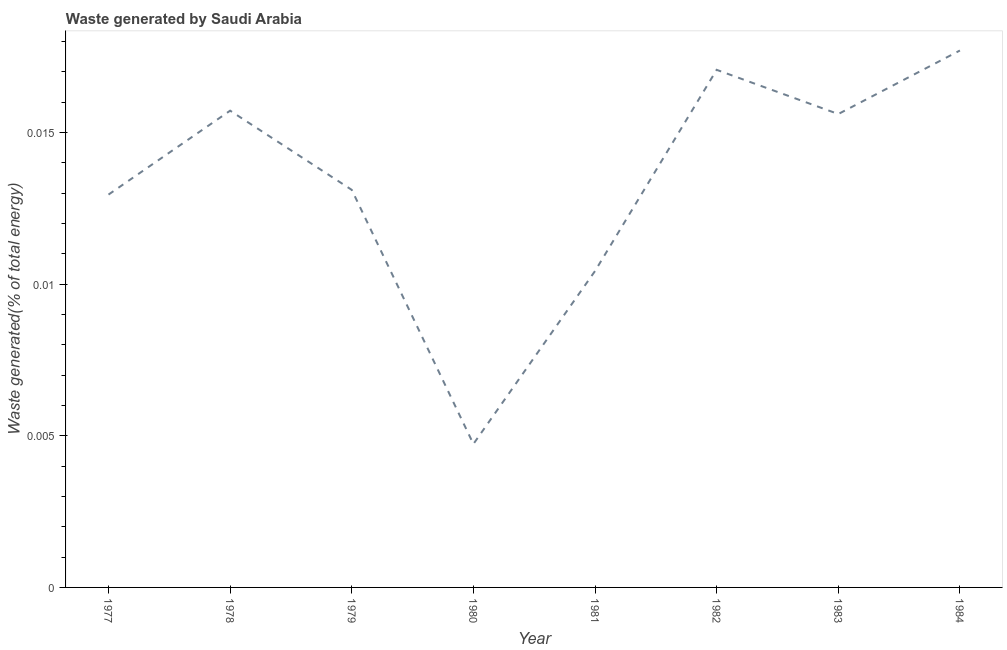What is the amount of waste generated in 1978?
Your response must be concise. 0.02. Across all years, what is the maximum amount of waste generated?
Offer a terse response. 0.02. Across all years, what is the minimum amount of waste generated?
Offer a very short reply. 0. What is the sum of the amount of waste generated?
Your answer should be compact. 0.11. What is the difference between the amount of waste generated in 1982 and 1984?
Your answer should be very brief. -0. What is the average amount of waste generated per year?
Make the answer very short. 0.01. What is the median amount of waste generated?
Keep it short and to the point. 0.01. Do a majority of the years between 1979 and 1983 (inclusive) have amount of waste generated greater than 0.009000000000000001 %?
Offer a terse response. Yes. What is the ratio of the amount of waste generated in 1977 to that in 1983?
Provide a succinct answer. 0.83. Is the amount of waste generated in 1978 less than that in 1981?
Ensure brevity in your answer.  No. Is the difference between the amount of waste generated in 1979 and 1982 greater than the difference between any two years?
Make the answer very short. No. What is the difference between the highest and the second highest amount of waste generated?
Provide a succinct answer. 0. Is the sum of the amount of waste generated in 1978 and 1983 greater than the maximum amount of waste generated across all years?
Offer a terse response. Yes. What is the difference between the highest and the lowest amount of waste generated?
Keep it short and to the point. 0.01. In how many years, is the amount of waste generated greater than the average amount of waste generated taken over all years?
Give a very brief answer. 4. How many lines are there?
Offer a very short reply. 1. What is the difference between two consecutive major ticks on the Y-axis?
Give a very brief answer. 0.01. What is the title of the graph?
Provide a succinct answer. Waste generated by Saudi Arabia. What is the label or title of the X-axis?
Offer a terse response. Year. What is the label or title of the Y-axis?
Your answer should be compact. Waste generated(% of total energy). What is the Waste generated(% of total energy) in 1977?
Offer a terse response. 0.01. What is the Waste generated(% of total energy) of 1978?
Keep it short and to the point. 0.02. What is the Waste generated(% of total energy) in 1979?
Provide a succinct answer. 0.01. What is the Waste generated(% of total energy) of 1980?
Keep it short and to the point. 0. What is the Waste generated(% of total energy) in 1981?
Your answer should be very brief. 0.01. What is the Waste generated(% of total energy) in 1982?
Offer a very short reply. 0.02. What is the Waste generated(% of total energy) of 1983?
Keep it short and to the point. 0.02. What is the Waste generated(% of total energy) of 1984?
Offer a very short reply. 0.02. What is the difference between the Waste generated(% of total energy) in 1977 and 1978?
Ensure brevity in your answer.  -0. What is the difference between the Waste generated(% of total energy) in 1977 and 1979?
Provide a succinct answer. -0. What is the difference between the Waste generated(% of total energy) in 1977 and 1980?
Your answer should be compact. 0.01. What is the difference between the Waste generated(% of total energy) in 1977 and 1981?
Make the answer very short. 0. What is the difference between the Waste generated(% of total energy) in 1977 and 1982?
Provide a short and direct response. -0. What is the difference between the Waste generated(% of total energy) in 1977 and 1983?
Keep it short and to the point. -0. What is the difference between the Waste generated(% of total energy) in 1977 and 1984?
Keep it short and to the point. -0. What is the difference between the Waste generated(% of total energy) in 1978 and 1979?
Ensure brevity in your answer.  0. What is the difference between the Waste generated(% of total energy) in 1978 and 1980?
Make the answer very short. 0.01. What is the difference between the Waste generated(% of total energy) in 1978 and 1981?
Make the answer very short. 0.01. What is the difference between the Waste generated(% of total energy) in 1978 and 1982?
Offer a terse response. -0. What is the difference between the Waste generated(% of total energy) in 1978 and 1983?
Provide a short and direct response. 0. What is the difference between the Waste generated(% of total energy) in 1978 and 1984?
Provide a short and direct response. -0. What is the difference between the Waste generated(% of total energy) in 1979 and 1980?
Offer a terse response. 0.01. What is the difference between the Waste generated(% of total energy) in 1979 and 1981?
Keep it short and to the point. 0. What is the difference between the Waste generated(% of total energy) in 1979 and 1982?
Your answer should be very brief. -0. What is the difference between the Waste generated(% of total energy) in 1979 and 1983?
Your response must be concise. -0. What is the difference between the Waste generated(% of total energy) in 1979 and 1984?
Provide a short and direct response. -0. What is the difference between the Waste generated(% of total energy) in 1980 and 1981?
Provide a short and direct response. -0.01. What is the difference between the Waste generated(% of total energy) in 1980 and 1982?
Your response must be concise. -0.01. What is the difference between the Waste generated(% of total energy) in 1980 and 1983?
Keep it short and to the point. -0.01. What is the difference between the Waste generated(% of total energy) in 1980 and 1984?
Ensure brevity in your answer.  -0.01. What is the difference between the Waste generated(% of total energy) in 1981 and 1982?
Provide a succinct answer. -0.01. What is the difference between the Waste generated(% of total energy) in 1981 and 1983?
Ensure brevity in your answer.  -0.01. What is the difference between the Waste generated(% of total energy) in 1981 and 1984?
Your response must be concise. -0.01. What is the difference between the Waste generated(% of total energy) in 1982 and 1983?
Offer a very short reply. 0. What is the difference between the Waste generated(% of total energy) in 1982 and 1984?
Provide a short and direct response. -0. What is the difference between the Waste generated(% of total energy) in 1983 and 1984?
Your response must be concise. -0. What is the ratio of the Waste generated(% of total energy) in 1977 to that in 1978?
Your answer should be compact. 0.82. What is the ratio of the Waste generated(% of total energy) in 1977 to that in 1979?
Provide a short and direct response. 0.99. What is the ratio of the Waste generated(% of total energy) in 1977 to that in 1980?
Offer a very short reply. 2.74. What is the ratio of the Waste generated(% of total energy) in 1977 to that in 1981?
Provide a short and direct response. 1.24. What is the ratio of the Waste generated(% of total energy) in 1977 to that in 1982?
Your response must be concise. 0.76. What is the ratio of the Waste generated(% of total energy) in 1977 to that in 1983?
Provide a short and direct response. 0.83. What is the ratio of the Waste generated(% of total energy) in 1977 to that in 1984?
Ensure brevity in your answer.  0.73. What is the ratio of the Waste generated(% of total energy) in 1978 to that in 1979?
Your response must be concise. 1.2. What is the ratio of the Waste generated(% of total energy) in 1978 to that in 1980?
Offer a terse response. 3.32. What is the ratio of the Waste generated(% of total energy) in 1978 to that in 1981?
Make the answer very short. 1.51. What is the ratio of the Waste generated(% of total energy) in 1978 to that in 1982?
Your answer should be compact. 0.92. What is the ratio of the Waste generated(% of total energy) in 1978 to that in 1984?
Provide a succinct answer. 0.89. What is the ratio of the Waste generated(% of total energy) in 1979 to that in 1980?
Your response must be concise. 2.77. What is the ratio of the Waste generated(% of total energy) in 1979 to that in 1981?
Offer a very short reply. 1.26. What is the ratio of the Waste generated(% of total energy) in 1979 to that in 1982?
Your response must be concise. 0.77. What is the ratio of the Waste generated(% of total energy) in 1979 to that in 1983?
Offer a terse response. 0.84. What is the ratio of the Waste generated(% of total energy) in 1979 to that in 1984?
Your answer should be compact. 0.74. What is the ratio of the Waste generated(% of total energy) in 1980 to that in 1981?
Keep it short and to the point. 0.45. What is the ratio of the Waste generated(% of total energy) in 1980 to that in 1982?
Ensure brevity in your answer.  0.28. What is the ratio of the Waste generated(% of total energy) in 1980 to that in 1983?
Give a very brief answer. 0.3. What is the ratio of the Waste generated(% of total energy) in 1980 to that in 1984?
Keep it short and to the point. 0.27. What is the ratio of the Waste generated(% of total energy) in 1981 to that in 1982?
Your response must be concise. 0.61. What is the ratio of the Waste generated(% of total energy) in 1981 to that in 1983?
Provide a short and direct response. 0.67. What is the ratio of the Waste generated(% of total energy) in 1981 to that in 1984?
Ensure brevity in your answer.  0.59. What is the ratio of the Waste generated(% of total energy) in 1982 to that in 1983?
Offer a terse response. 1.09. What is the ratio of the Waste generated(% of total energy) in 1982 to that in 1984?
Provide a succinct answer. 0.96. What is the ratio of the Waste generated(% of total energy) in 1983 to that in 1984?
Offer a very short reply. 0.88. 